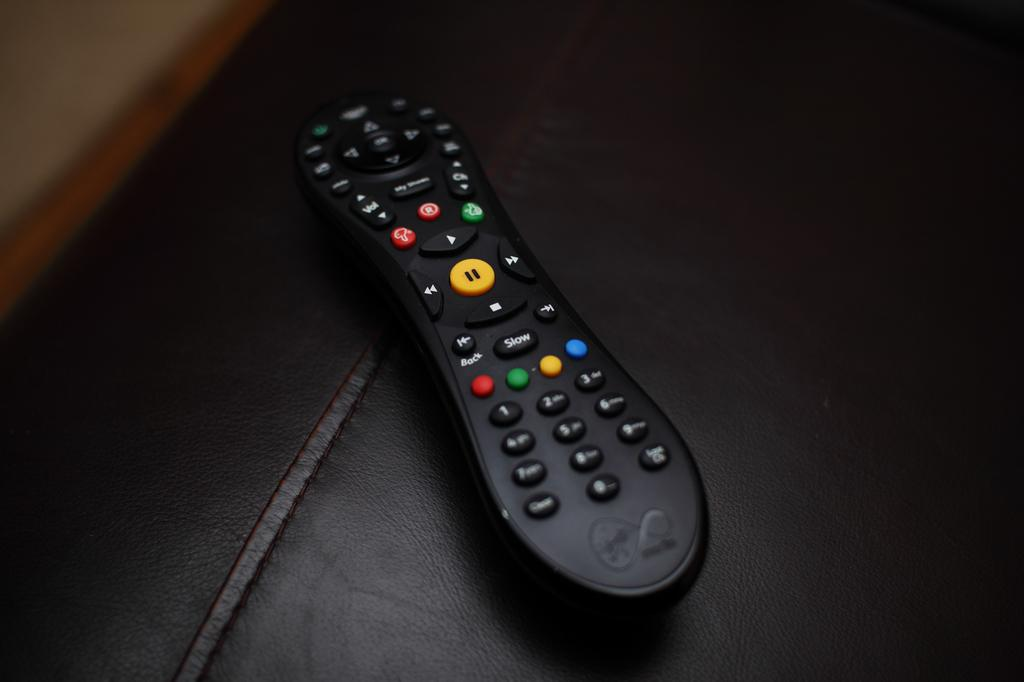<image>
Provide a brief description of the given image. A remote control features four colored buttons right below the "slow" button. 